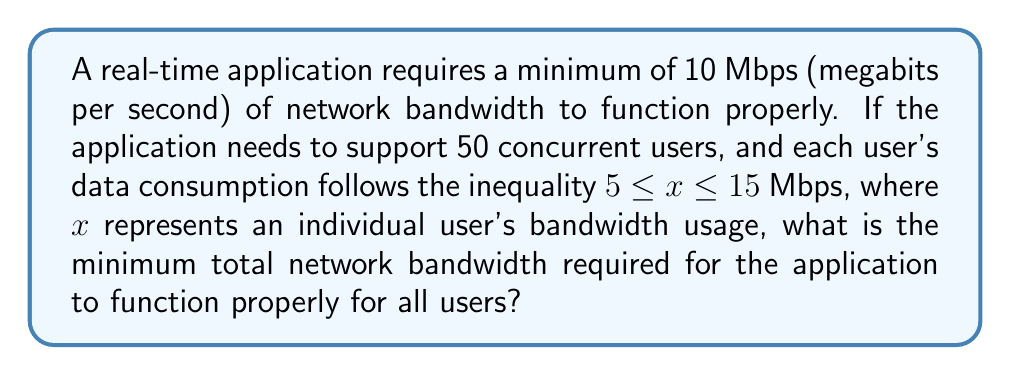Help me with this question. Let's approach this step-by-step:

1. Understand the given information:
   - The application requires a minimum of 10 Mbps to function properly.
   - There are 50 concurrent users.
   - Each user's bandwidth usage $(x)$ is between 5 and 15 Mbps: $5 \leq x \leq 15$

2. Calculate the minimum bandwidth for all users:
   - Since we need to find the minimum, we use the lower bound of the inequality.
   - Minimum bandwidth per user = 5 Mbps
   - Total minimum bandwidth for all users = $50 \times 5 = 250$ Mbps

3. Compare with the application's minimum requirement:
   - Application's minimum requirement = 10 Mbps
   - User's total minimum requirement = 250 Mbps
   - $250 > 10$, so we use the larger value

4. Therefore, the minimum total network bandwidth required is 250 Mbps.

This ensures that even if all users are operating at the minimum bandwidth, the application will still function properly for everyone.
Answer: 250 Mbps 